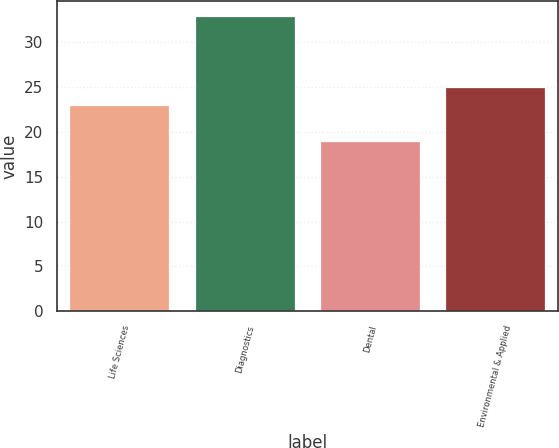<chart> <loc_0><loc_0><loc_500><loc_500><bar_chart><fcel>Life Sciences<fcel>Diagnostics<fcel>Dental<fcel>Environmental & Applied<nl><fcel>23<fcel>33<fcel>19<fcel>25<nl></chart> 